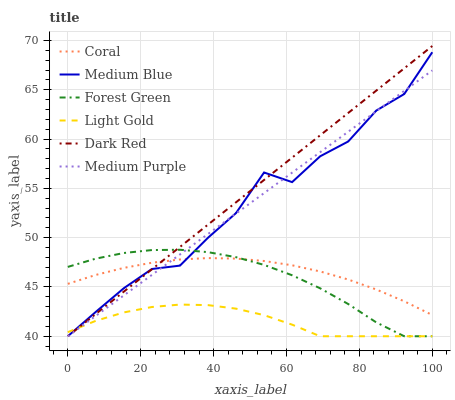Does Light Gold have the minimum area under the curve?
Answer yes or no. Yes. Does Dark Red have the maximum area under the curve?
Answer yes or no. Yes. Does Coral have the minimum area under the curve?
Answer yes or no. No. Does Coral have the maximum area under the curve?
Answer yes or no. No. Is Dark Red the smoothest?
Answer yes or no. Yes. Is Medium Blue the roughest?
Answer yes or no. Yes. Is Coral the smoothest?
Answer yes or no. No. Is Coral the roughest?
Answer yes or no. No. Does Dark Red have the lowest value?
Answer yes or no. Yes. Does Coral have the lowest value?
Answer yes or no. No. Does Dark Red have the highest value?
Answer yes or no. Yes. Does Coral have the highest value?
Answer yes or no. No. Is Light Gold less than Coral?
Answer yes or no. Yes. Is Coral greater than Light Gold?
Answer yes or no. Yes. Does Medium Blue intersect Coral?
Answer yes or no. Yes. Is Medium Blue less than Coral?
Answer yes or no. No. Is Medium Blue greater than Coral?
Answer yes or no. No. Does Light Gold intersect Coral?
Answer yes or no. No. 